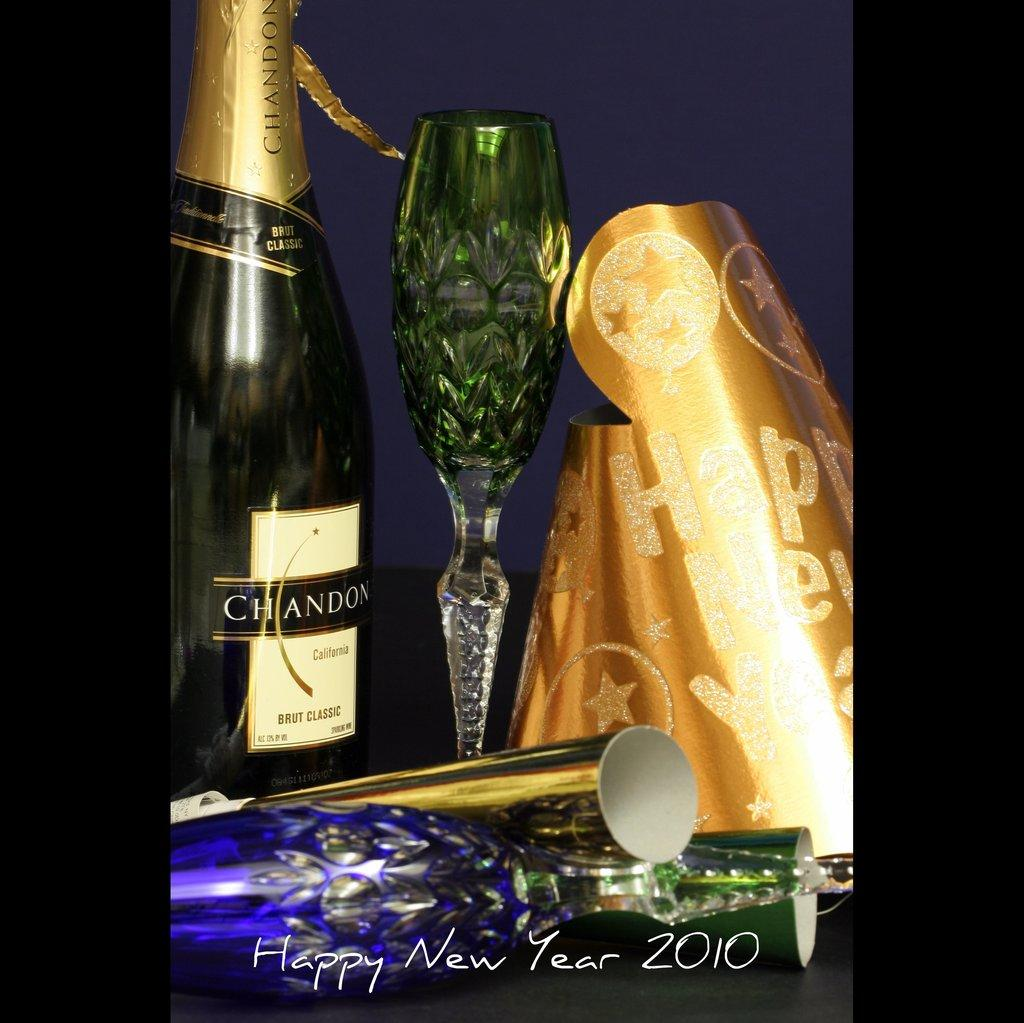What type of beverage container is in the image? There is a wine bottle in the image. What might be used to drink the beverage from the wine bottle? There is a glass in the image. What else can be seen on the table in the image? There are other objects on the table in the image. What is visible in the background of the image? There is a wall in the background of the image. What actor can be seen in the image? There is no actor present in the image. 